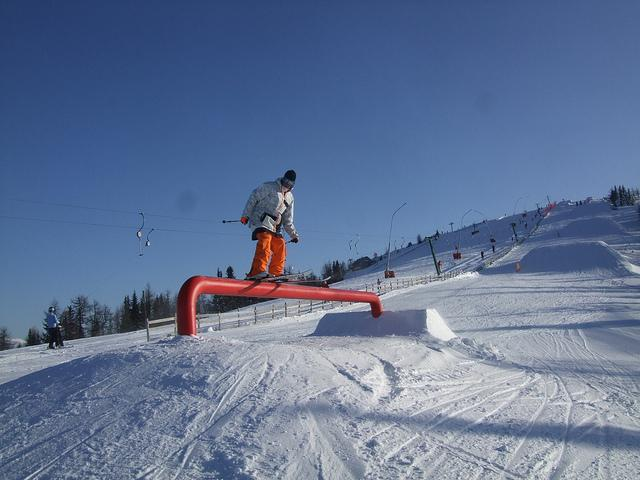What is the man going to do next? jump 